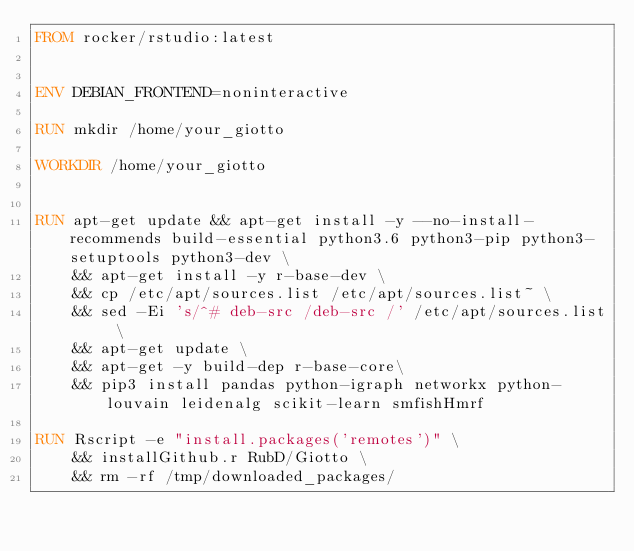Convert code to text. <code><loc_0><loc_0><loc_500><loc_500><_Dockerfile_>FROM rocker/rstudio:latest


ENV DEBIAN_FRONTEND=noninteractive

RUN mkdir /home/your_giotto

WORKDIR /home/your_giotto

        
RUN apt-get update && apt-get install -y --no-install-recommends build-essential python3.6 python3-pip python3-setuptools python3-dev \
    && apt-get install -y r-base-dev \
    && cp /etc/apt/sources.list /etc/apt/sources.list~ \
    && sed -Ei 's/^# deb-src /deb-src /' /etc/apt/sources.list \
    && apt-get update \
    && apt-get -y build-dep r-base-core\
    && pip3 install pandas python-igraph networkx python-louvain leidenalg scikit-learn smfishHmrf

RUN Rscript -e "install.packages('remotes')" \
    && installGithub.r RubD/Giotto \
    && rm -rf /tmp/downloaded_packages/</code> 